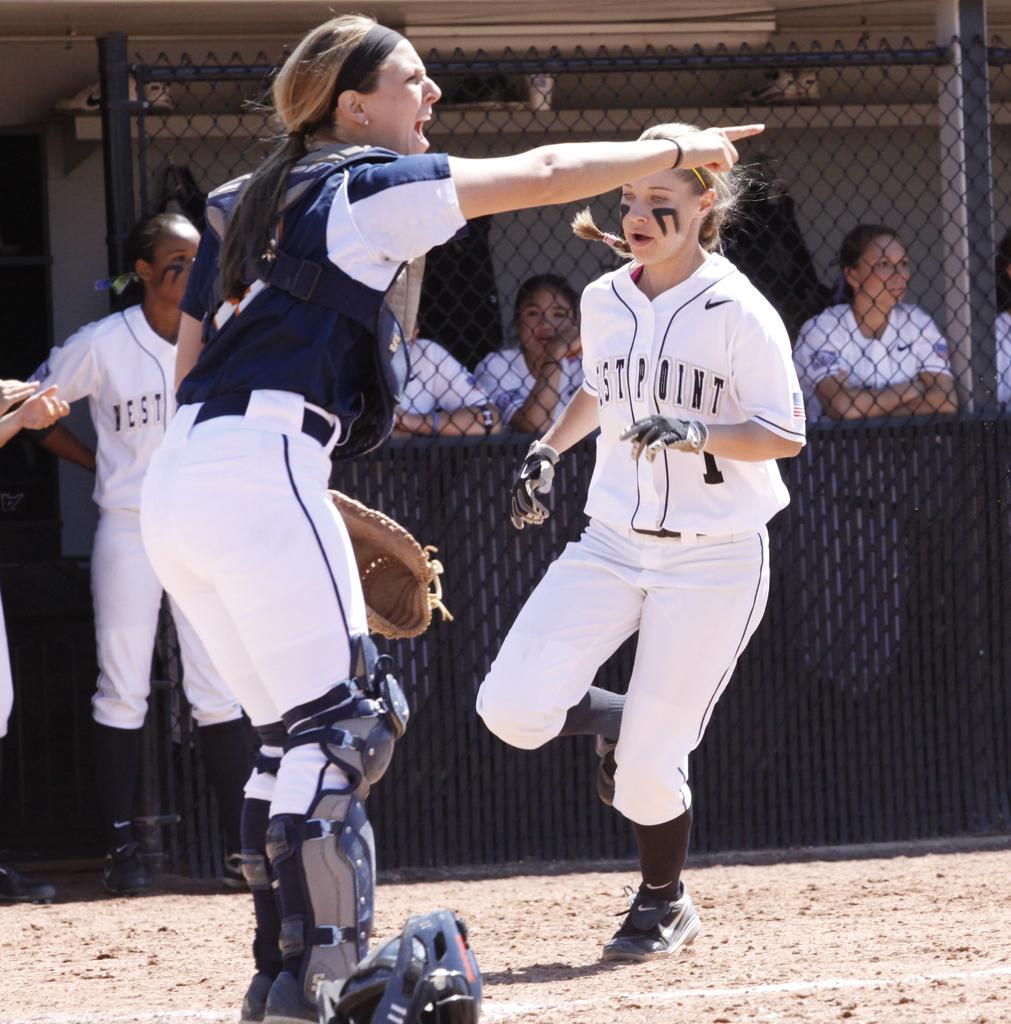<image>
Offer a succinct explanation of the picture presented. a player of Westpoint is running to the base 